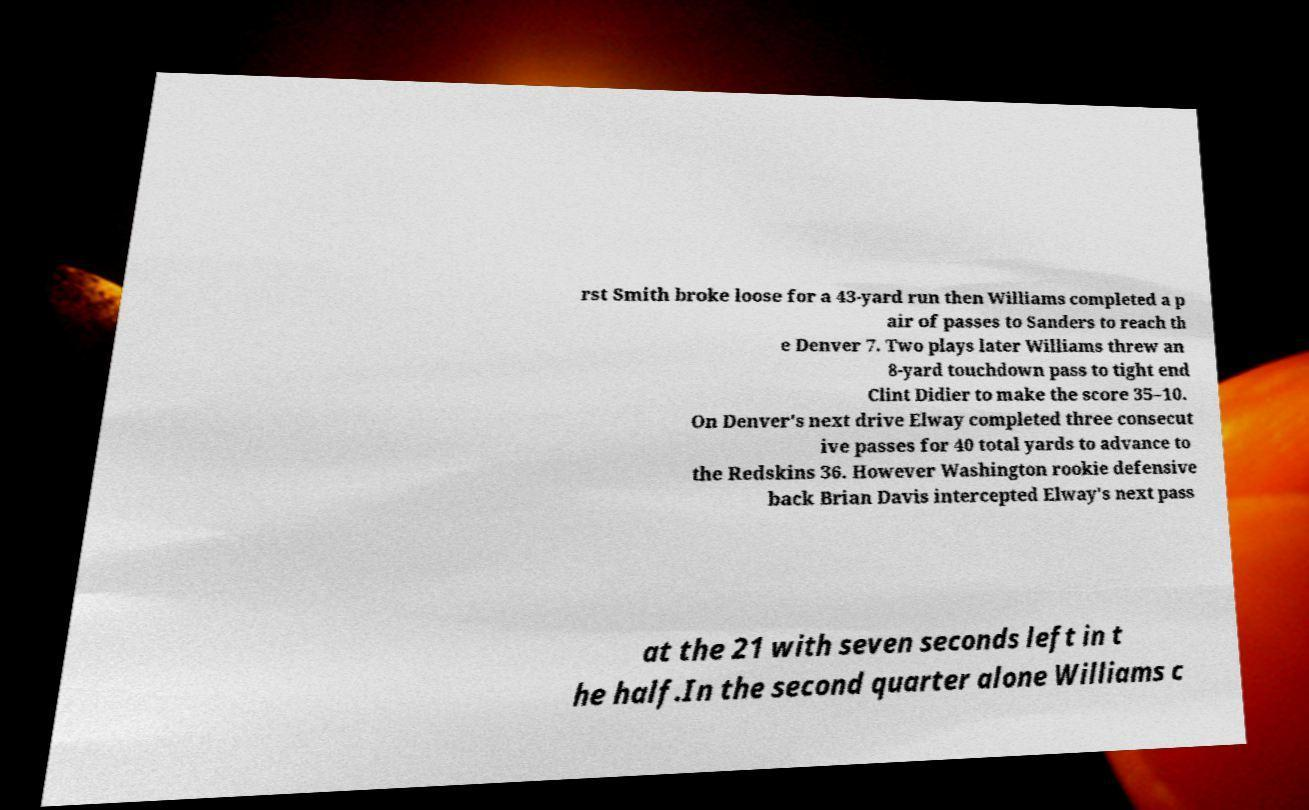What messages or text are displayed in this image? I need them in a readable, typed format. rst Smith broke loose for a 43-yard run then Williams completed a p air of passes to Sanders to reach th e Denver 7. Two plays later Williams threw an 8-yard touchdown pass to tight end Clint Didier to make the score 35–10. On Denver's next drive Elway completed three consecut ive passes for 40 total yards to advance to the Redskins 36. However Washington rookie defensive back Brian Davis intercepted Elway's next pass at the 21 with seven seconds left in t he half.In the second quarter alone Williams c 